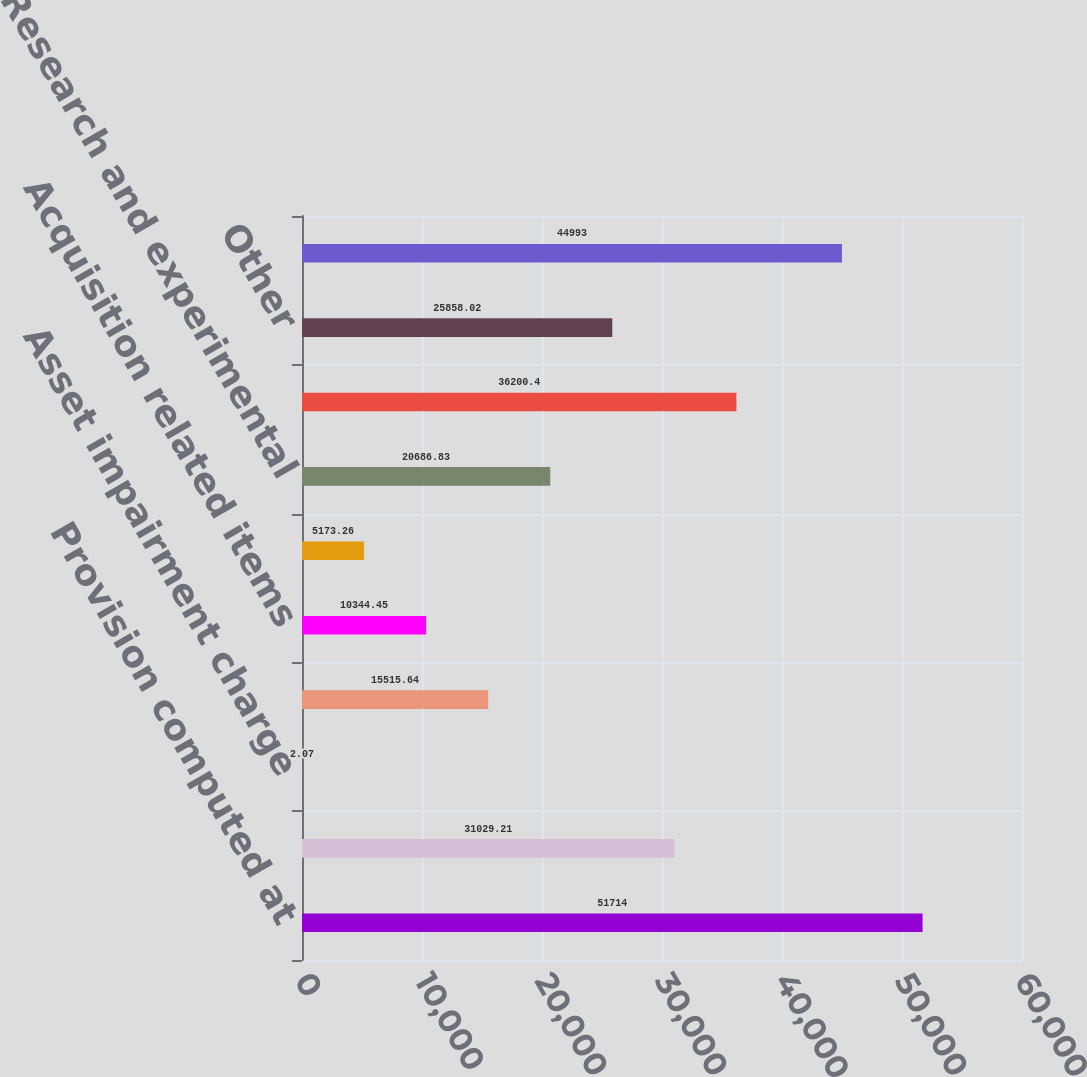<chart> <loc_0><loc_0><loc_500><loc_500><bar_chart><fcel>Provision computed at<fcel>State income tax net of<fcel>Asset impairment charge<fcel>Tax-exempt interest income<fcel>Acquisition related items<fcel>Domestic manufacturing<fcel>Research and experimental<fcel>Foreign rate differential<fcel>Other<fcel>Provision for income taxes<nl><fcel>51714<fcel>31029.2<fcel>2.07<fcel>15515.6<fcel>10344.5<fcel>5173.26<fcel>20686.8<fcel>36200.4<fcel>25858<fcel>44993<nl></chart> 